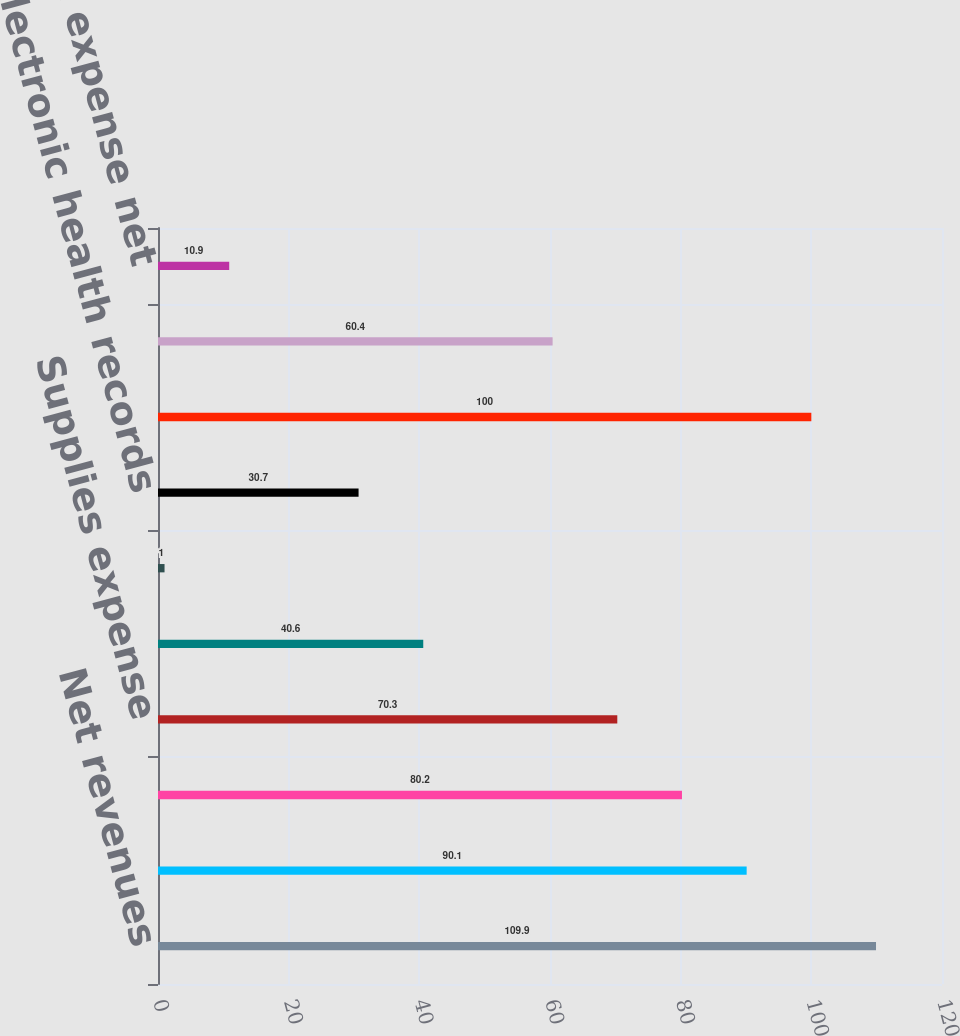Convert chart to OTSL. <chart><loc_0><loc_0><loc_500><loc_500><bar_chart><fcel>Net revenues<fcel>Salaries wages and benefits<fcel>Other operating expenses<fcel>Supplies expense<fcel>Depreciation and amortization<fcel>Lease and rental expense<fcel>Electronic health records<fcel>Subtotal-operating expenses<fcel>Income from operations<fcel>Interest expense net<nl><fcel>109.9<fcel>90.1<fcel>80.2<fcel>70.3<fcel>40.6<fcel>1<fcel>30.7<fcel>100<fcel>60.4<fcel>10.9<nl></chart> 